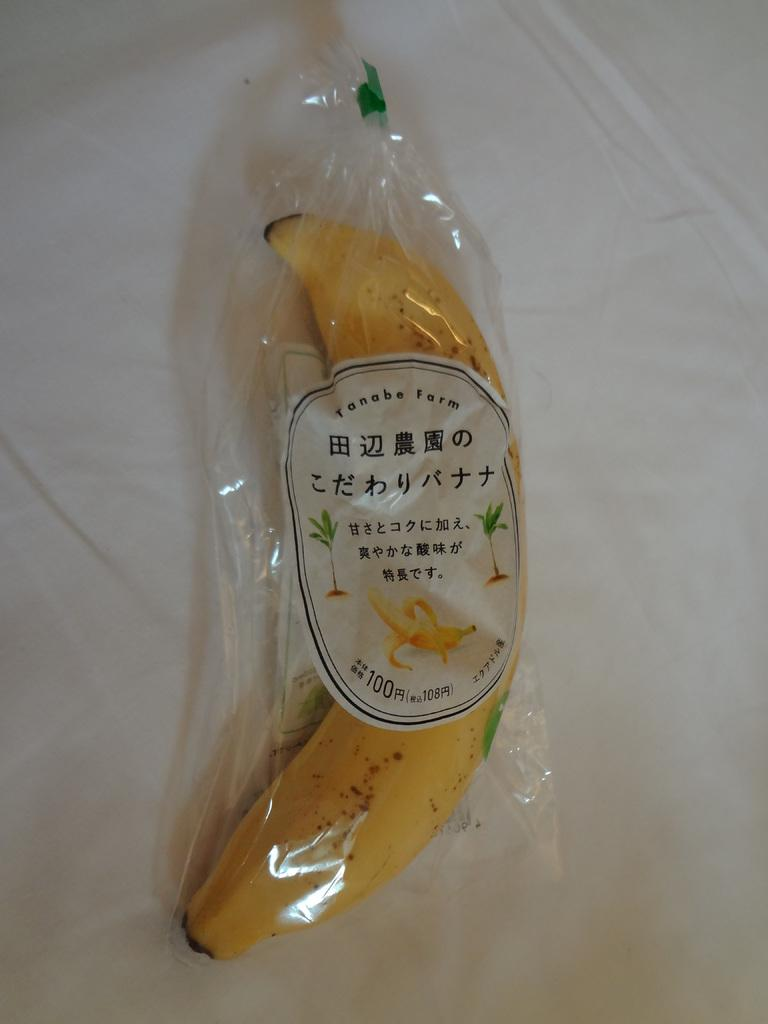Provide a one-sentence caption for the provided image. A banana wrapped in plastic that came from Tanabe Farm. 